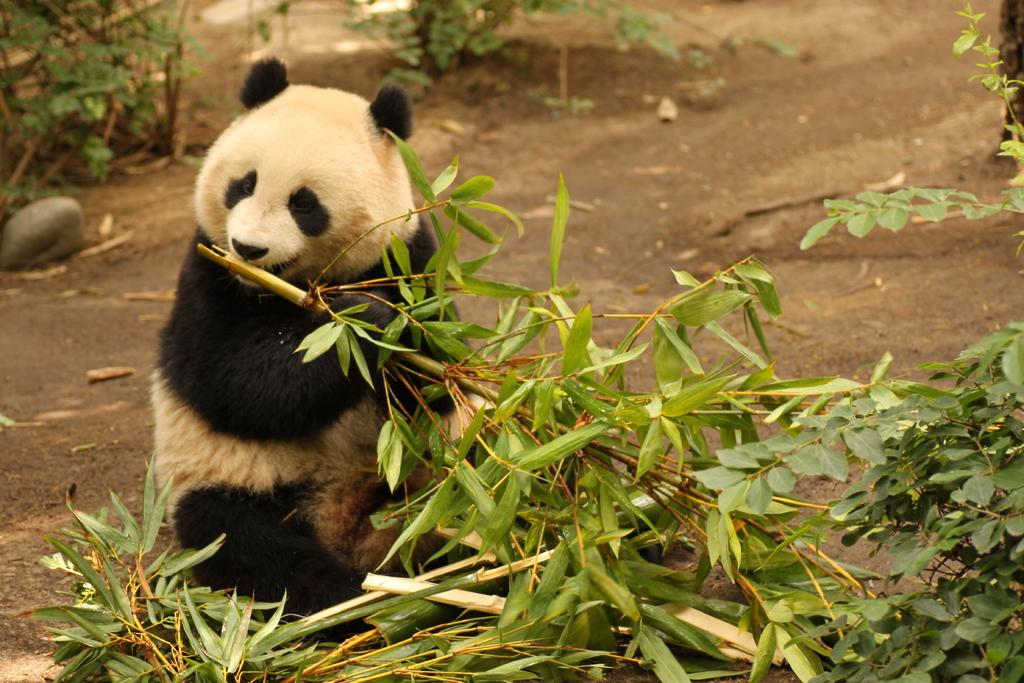What animal is present in the image? There is a panda in the image. What colors can be seen on the panda? The panda is white and black in color. What type of vegetation is visible in the image? There are leaves visible in the image. What inanimate object can be seen in the image? There is a stone in the image. What type of paint is the panda using to color the banana in the image? There is no paint or banana present in the image; it features a panda and leaves. How does the rail system function in the image? There is no rail system present in the image. 